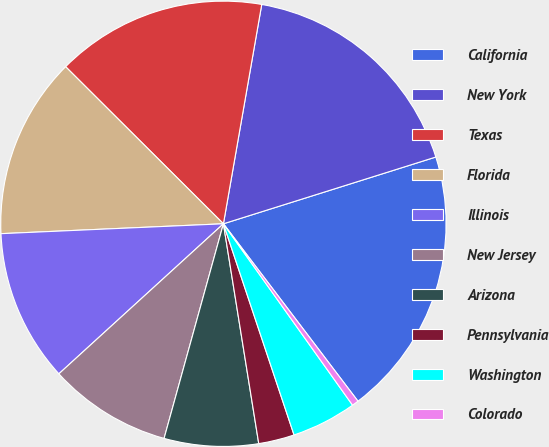Convert chart. <chart><loc_0><loc_0><loc_500><loc_500><pie_chart><fcel>California<fcel>New York<fcel>Texas<fcel>Florida<fcel>Illinois<fcel>New Jersey<fcel>Arizona<fcel>Pennsylvania<fcel>Washington<fcel>Colorado<nl><fcel>19.52%<fcel>17.4%<fcel>15.29%<fcel>13.17%<fcel>11.06%<fcel>8.94%<fcel>6.83%<fcel>2.6%<fcel>4.71%<fcel>0.48%<nl></chart> 